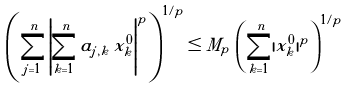Convert formula to latex. <formula><loc_0><loc_0><loc_500><loc_500>\left ( \sum _ { j = 1 } ^ { n } \left | \sum _ { k = 1 } ^ { n } a _ { j , k } \, x ^ { 0 } _ { k } \right | ^ { p } \right ) ^ { 1 / p } \leq M _ { p } \, \left ( \sum _ { k = 1 } ^ { n } | x ^ { 0 } _ { k } | ^ { p } \right ) ^ { 1 / p }</formula> 